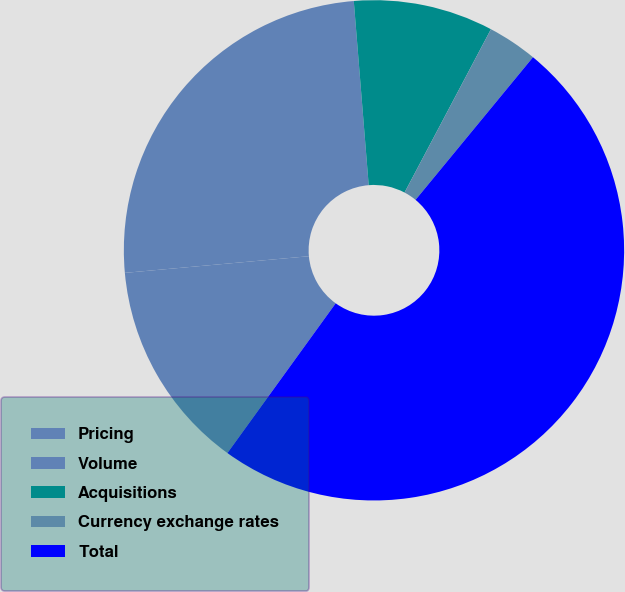<chart> <loc_0><loc_0><loc_500><loc_500><pie_chart><fcel>Pricing<fcel>Volume<fcel>Acquisitions<fcel>Currency exchange rates<fcel>Total<nl><fcel>13.6%<fcel>25.15%<fcel>9.03%<fcel>3.22%<fcel>49.0%<nl></chart> 